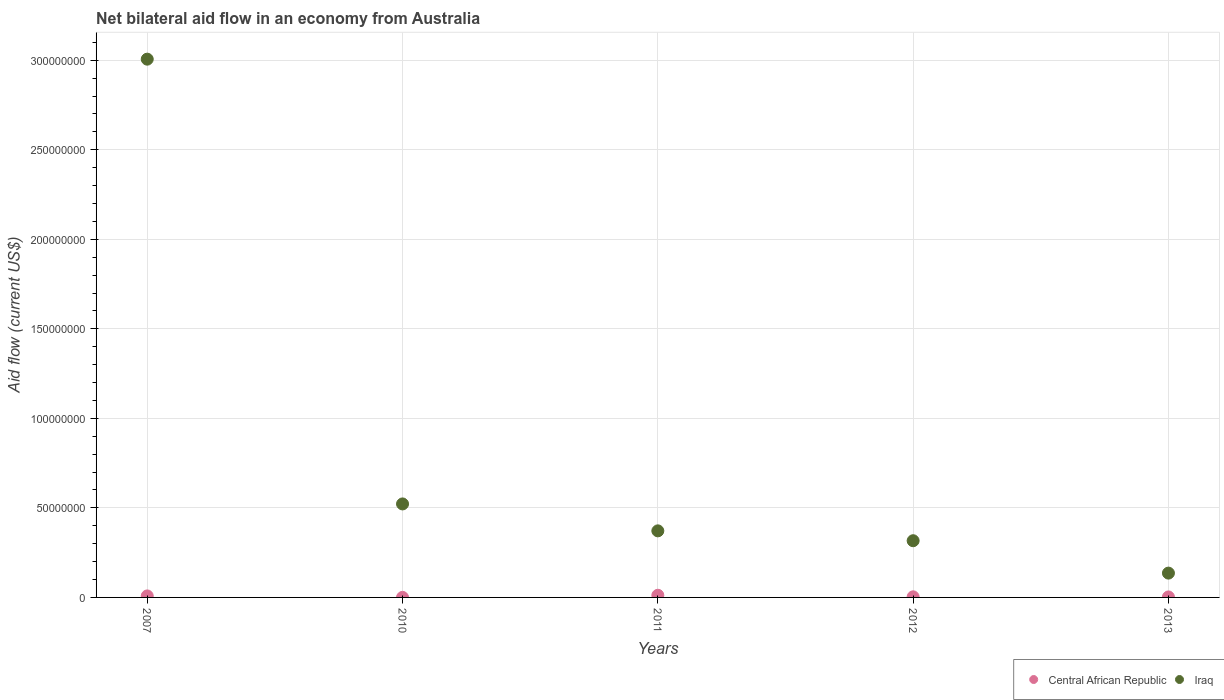Is the number of dotlines equal to the number of legend labels?
Keep it short and to the point. Yes. What is the net bilateral aid flow in Iraq in 2012?
Offer a terse response. 3.17e+07. Across all years, what is the maximum net bilateral aid flow in Iraq?
Your answer should be compact. 3.01e+08. Across all years, what is the minimum net bilateral aid flow in Iraq?
Provide a succinct answer. 1.36e+07. In which year was the net bilateral aid flow in Central African Republic maximum?
Your response must be concise. 2011. In which year was the net bilateral aid flow in Central African Republic minimum?
Your answer should be compact. 2010. What is the total net bilateral aid flow in Central African Republic in the graph?
Your answer should be very brief. 2.68e+06. What is the difference between the net bilateral aid flow in Iraq in 2007 and that in 2012?
Offer a terse response. 2.69e+08. What is the difference between the net bilateral aid flow in Central African Republic in 2010 and the net bilateral aid flow in Iraq in 2012?
Provide a short and direct response. -3.16e+07. What is the average net bilateral aid flow in Central African Republic per year?
Keep it short and to the point. 5.36e+05. In the year 2010, what is the difference between the net bilateral aid flow in Iraq and net bilateral aid flow in Central African Republic?
Make the answer very short. 5.22e+07. In how many years, is the net bilateral aid flow in Iraq greater than 90000000 US$?
Your answer should be very brief. 1. What is the ratio of the net bilateral aid flow in Iraq in 2010 to that in 2013?
Offer a terse response. 3.85. Is the difference between the net bilateral aid flow in Iraq in 2007 and 2011 greater than the difference between the net bilateral aid flow in Central African Republic in 2007 and 2011?
Give a very brief answer. Yes. What is the difference between the highest and the lowest net bilateral aid flow in Iraq?
Your answer should be compact. 2.87e+08. In how many years, is the net bilateral aid flow in Iraq greater than the average net bilateral aid flow in Iraq taken over all years?
Your response must be concise. 1. Does the net bilateral aid flow in Central African Republic monotonically increase over the years?
Make the answer very short. No. Is the net bilateral aid flow in Iraq strictly greater than the net bilateral aid flow in Central African Republic over the years?
Your response must be concise. Yes. How many years are there in the graph?
Offer a terse response. 5. Where does the legend appear in the graph?
Keep it short and to the point. Bottom right. What is the title of the graph?
Offer a very short reply. Net bilateral aid flow in an economy from Australia. Does "Honduras" appear as one of the legend labels in the graph?
Give a very brief answer. No. What is the label or title of the X-axis?
Offer a terse response. Years. What is the Aid flow (current US$) in Central African Republic in 2007?
Keep it short and to the point. 8.40e+05. What is the Aid flow (current US$) in Iraq in 2007?
Give a very brief answer. 3.01e+08. What is the Aid flow (current US$) in Central African Republic in 2010?
Offer a very short reply. 3.00e+04. What is the Aid flow (current US$) in Iraq in 2010?
Provide a short and direct response. 5.22e+07. What is the Aid flow (current US$) in Central African Republic in 2011?
Provide a short and direct response. 1.21e+06. What is the Aid flow (current US$) of Iraq in 2011?
Your response must be concise. 3.72e+07. What is the Aid flow (current US$) in Central African Republic in 2012?
Offer a very short reply. 3.30e+05. What is the Aid flow (current US$) of Iraq in 2012?
Offer a very short reply. 3.17e+07. What is the Aid flow (current US$) in Iraq in 2013?
Your answer should be compact. 1.36e+07. Across all years, what is the maximum Aid flow (current US$) in Central African Republic?
Your answer should be very brief. 1.21e+06. Across all years, what is the maximum Aid flow (current US$) of Iraq?
Provide a short and direct response. 3.01e+08. Across all years, what is the minimum Aid flow (current US$) of Iraq?
Provide a short and direct response. 1.36e+07. What is the total Aid flow (current US$) of Central African Republic in the graph?
Your answer should be compact. 2.68e+06. What is the total Aid flow (current US$) of Iraq in the graph?
Offer a very short reply. 4.35e+08. What is the difference between the Aid flow (current US$) of Central African Republic in 2007 and that in 2010?
Make the answer very short. 8.10e+05. What is the difference between the Aid flow (current US$) in Iraq in 2007 and that in 2010?
Ensure brevity in your answer.  2.48e+08. What is the difference between the Aid flow (current US$) of Central African Republic in 2007 and that in 2011?
Your answer should be very brief. -3.70e+05. What is the difference between the Aid flow (current US$) in Iraq in 2007 and that in 2011?
Ensure brevity in your answer.  2.63e+08. What is the difference between the Aid flow (current US$) of Central African Republic in 2007 and that in 2012?
Make the answer very short. 5.10e+05. What is the difference between the Aid flow (current US$) of Iraq in 2007 and that in 2012?
Offer a very short reply. 2.69e+08. What is the difference between the Aid flow (current US$) in Central African Republic in 2007 and that in 2013?
Your response must be concise. 5.70e+05. What is the difference between the Aid flow (current US$) of Iraq in 2007 and that in 2013?
Offer a very short reply. 2.87e+08. What is the difference between the Aid flow (current US$) in Central African Republic in 2010 and that in 2011?
Keep it short and to the point. -1.18e+06. What is the difference between the Aid flow (current US$) of Iraq in 2010 and that in 2011?
Ensure brevity in your answer.  1.50e+07. What is the difference between the Aid flow (current US$) of Iraq in 2010 and that in 2012?
Your answer should be very brief. 2.06e+07. What is the difference between the Aid flow (current US$) in Iraq in 2010 and that in 2013?
Provide a short and direct response. 3.86e+07. What is the difference between the Aid flow (current US$) of Central African Republic in 2011 and that in 2012?
Offer a terse response. 8.80e+05. What is the difference between the Aid flow (current US$) in Iraq in 2011 and that in 2012?
Your response must be concise. 5.51e+06. What is the difference between the Aid flow (current US$) in Central African Republic in 2011 and that in 2013?
Offer a very short reply. 9.40e+05. What is the difference between the Aid flow (current US$) in Iraq in 2011 and that in 2013?
Keep it short and to the point. 2.36e+07. What is the difference between the Aid flow (current US$) in Iraq in 2012 and that in 2013?
Provide a succinct answer. 1.81e+07. What is the difference between the Aid flow (current US$) in Central African Republic in 2007 and the Aid flow (current US$) in Iraq in 2010?
Make the answer very short. -5.14e+07. What is the difference between the Aid flow (current US$) of Central African Republic in 2007 and the Aid flow (current US$) of Iraq in 2011?
Give a very brief answer. -3.63e+07. What is the difference between the Aid flow (current US$) of Central African Republic in 2007 and the Aid flow (current US$) of Iraq in 2012?
Keep it short and to the point. -3.08e+07. What is the difference between the Aid flow (current US$) of Central African Republic in 2007 and the Aid flow (current US$) of Iraq in 2013?
Provide a short and direct response. -1.27e+07. What is the difference between the Aid flow (current US$) in Central African Republic in 2010 and the Aid flow (current US$) in Iraq in 2011?
Provide a succinct answer. -3.72e+07. What is the difference between the Aid flow (current US$) of Central African Republic in 2010 and the Aid flow (current US$) of Iraq in 2012?
Offer a terse response. -3.16e+07. What is the difference between the Aid flow (current US$) in Central African Republic in 2010 and the Aid flow (current US$) in Iraq in 2013?
Offer a very short reply. -1.36e+07. What is the difference between the Aid flow (current US$) in Central African Republic in 2011 and the Aid flow (current US$) in Iraq in 2012?
Give a very brief answer. -3.05e+07. What is the difference between the Aid flow (current US$) in Central African Republic in 2011 and the Aid flow (current US$) in Iraq in 2013?
Keep it short and to the point. -1.24e+07. What is the difference between the Aid flow (current US$) in Central African Republic in 2012 and the Aid flow (current US$) in Iraq in 2013?
Your answer should be compact. -1.32e+07. What is the average Aid flow (current US$) of Central African Republic per year?
Your answer should be very brief. 5.36e+05. What is the average Aid flow (current US$) in Iraq per year?
Provide a succinct answer. 8.71e+07. In the year 2007, what is the difference between the Aid flow (current US$) of Central African Republic and Aid flow (current US$) of Iraq?
Your answer should be compact. -3.00e+08. In the year 2010, what is the difference between the Aid flow (current US$) in Central African Republic and Aid flow (current US$) in Iraq?
Your answer should be compact. -5.22e+07. In the year 2011, what is the difference between the Aid flow (current US$) in Central African Republic and Aid flow (current US$) in Iraq?
Your response must be concise. -3.60e+07. In the year 2012, what is the difference between the Aid flow (current US$) of Central African Republic and Aid flow (current US$) of Iraq?
Your response must be concise. -3.13e+07. In the year 2013, what is the difference between the Aid flow (current US$) of Central African Republic and Aid flow (current US$) of Iraq?
Keep it short and to the point. -1.33e+07. What is the ratio of the Aid flow (current US$) of Central African Republic in 2007 to that in 2010?
Keep it short and to the point. 28. What is the ratio of the Aid flow (current US$) in Iraq in 2007 to that in 2010?
Your answer should be very brief. 5.76. What is the ratio of the Aid flow (current US$) of Central African Republic in 2007 to that in 2011?
Offer a terse response. 0.69. What is the ratio of the Aid flow (current US$) in Iraq in 2007 to that in 2011?
Make the answer very short. 8.09. What is the ratio of the Aid flow (current US$) in Central African Republic in 2007 to that in 2012?
Your response must be concise. 2.55. What is the ratio of the Aid flow (current US$) of Iraq in 2007 to that in 2012?
Give a very brief answer. 9.49. What is the ratio of the Aid flow (current US$) of Central African Republic in 2007 to that in 2013?
Offer a very short reply. 3.11. What is the ratio of the Aid flow (current US$) in Iraq in 2007 to that in 2013?
Your answer should be compact. 22.14. What is the ratio of the Aid flow (current US$) of Central African Republic in 2010 to that in 2011?
Offer a very short reply. 0.02. What is the ratio of the Aid flow (current US$) in Iraq in 2010 to that in 2011?
Your response must be concise. 1.4. What is the ratio of the Aid flow (current US$) of Central African Republic in 2010 to that in 2012?
Make the answer very short. 0.09. What is the ratio of the Aid flow (current US$) in Iraq in 2010 to that in 2012?
Your answer should be very brief. 1.65. What is the ratio of the Aid flow (current US$) in Iraq in 2010 to that in 2013?
Provide a succinct answer. 3.85. What is the ratio of the Aid flow (current US$) of Central African Republic in 2011 to that in 2012?
Your answer should be compact. 3.67. What is the ratio of the Aid flow (current US$) of Iraq in 2011 to that in 2012?
Offer a very short reply. 1.17. What is the ratio of the Aid flow (current US$) in Central African Republic in 2011 to that in 2013?
Your response must be concise. 4.48. What is the ratio of the Aid flow (current US$) in Iraq in 2011 to that in 2013?
Your answer should be very brief. 2.74. What is the ratio of the Aid flow (current US$) in Central African Republic in 2012 to that in 2013?
Provide a succinct answer. 1.22. What is the ratio of the Aid flow (current US$) of Iraq in 2012 to that in 2013?
Ensure brevity in your answer.  2.33. What is the difference between the highest and the second highest Aid flow (current US$) in Central African Republic?
Offer a very short reply. 3.70e+05. What is the difference between the highest and the second highest Aid flow (current US$) of Iraq?
Provide a succinct answer. 2.48e+08. What is the difference between the highest and the lowest Aid flow (current US$) of Central African Republic?
Offer a very short reply. 1.18e+06. What is the difference between the highest and the lowest Aid flow (current US$) of Iraq?
Provide a succinct answer. 2.87e+08. 